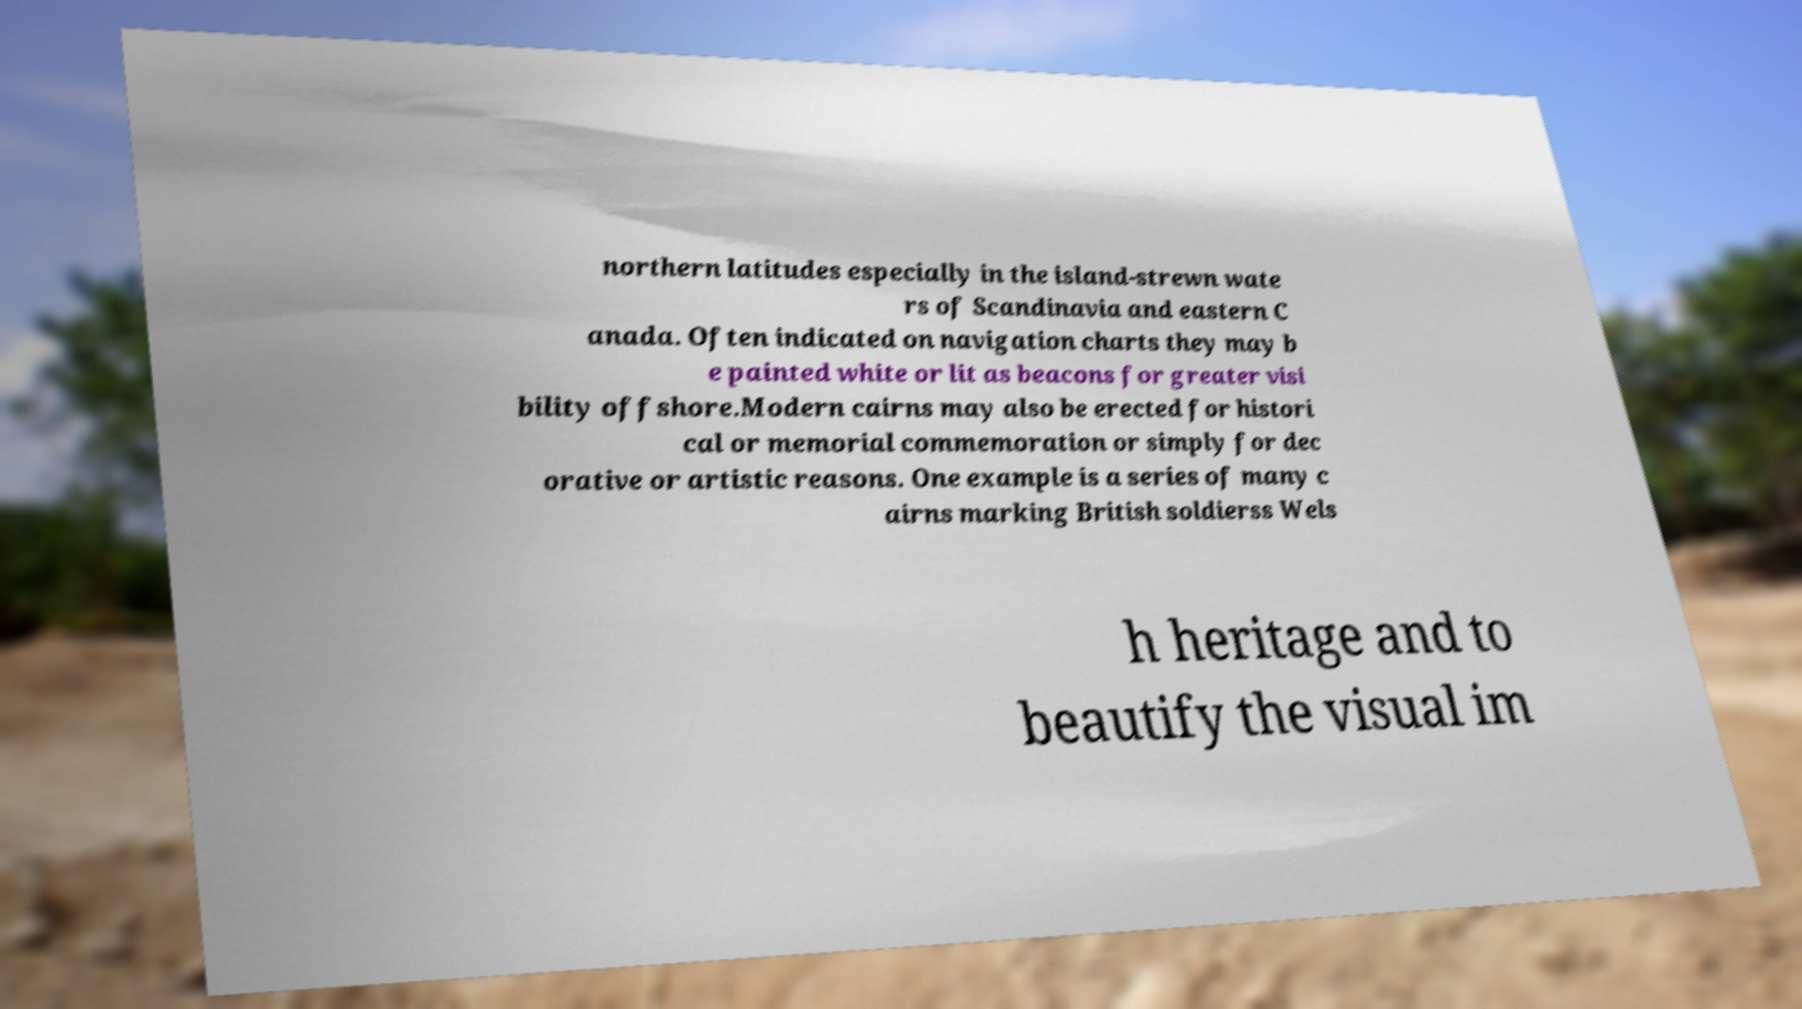Please identify and transcribe the text found in this image. northern latitudes especially in the island-strewn wate rs of Scandinavia and eastern C anada. Often indicated on navigation charts they may b e painted white or lit as beacons for greater visi bility offshore.Modern cairns may also be erected for histori cal or memorial commemoration or simply for dec orative or artistic reasons. One example is a series of many c airns marking British soldierss Wels h heritage and to beautify the visual im 